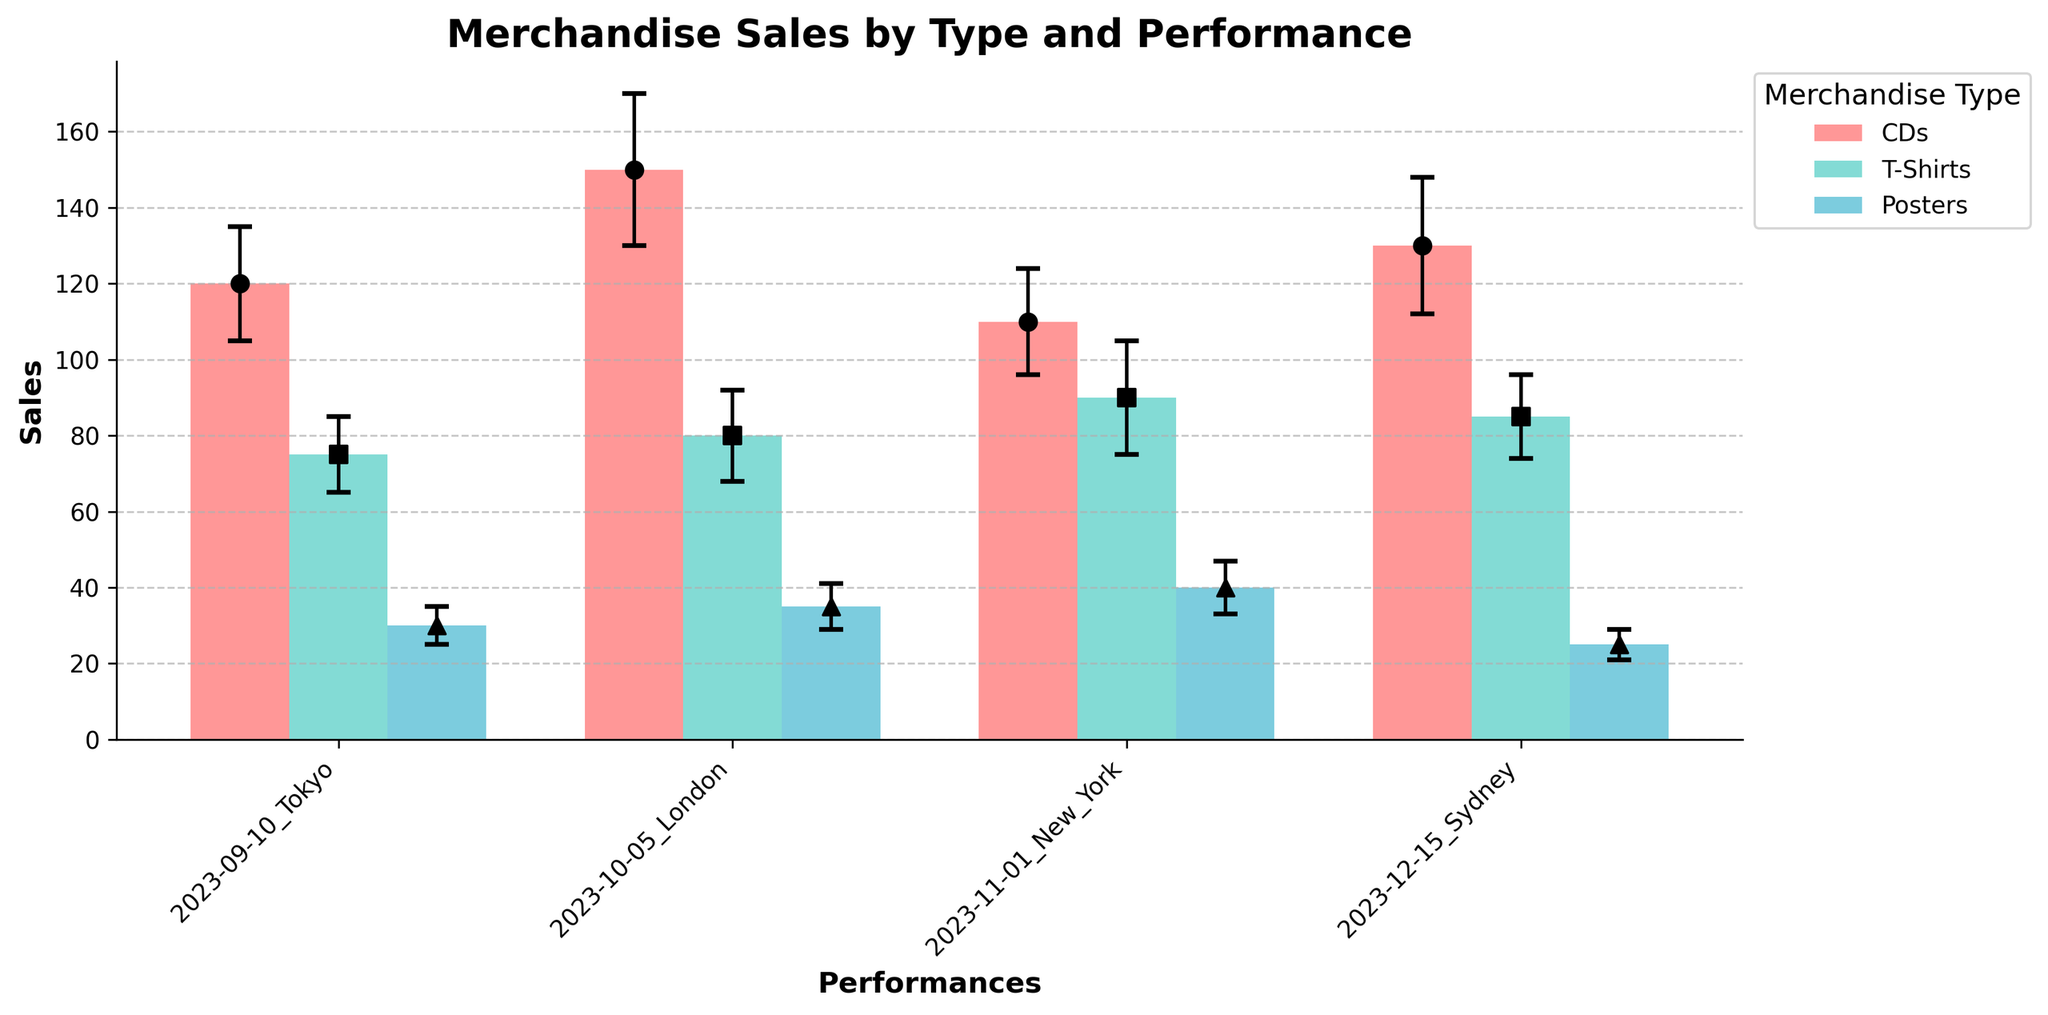What is the title of the plot? The plot title is typically placed at the top of the figure. In this case, the title is "Merchandise Sales by Type and Performance," clearly indicating the content of the plot.
Answer: Merchandise Sales by Type and Performance How many performance locations are shown in the plot? The performance locations can be identified by looking at the x-axis labels of the plot. In this case, the labels are "2023-09-10_Tokyo," "2023-10-05_London," "2023-11-01_New_York," and "2023-12-15_Sydney," which means there are four performance locations.
Answer: 4 Which merchandise type consistently shows the highest mean sales across all performances? By comparing the mean sales bars for each merchandise type across all performances, it is evident that CDs consistently have the highest mean sales compared to T-Shirts and Posters.
Answer: CDs What is the mean sales value of T-Shirts in London? To find this value, look at the bar representing T-Shirt sales for the "2023-10-05_London" performance. The mean sales value for T-Shirts in London is given as 80.
Answer: 80 What is the error margin for Poster sales in New York? Error margins are represented by the error bars extending above and below the mean sales bars. For Posters in New York (2023-11-01), the error margin is given as 7.
Answer: 7 Which performance location has the lowest mean sales for Posters, and what is the value? By comparing the heights of the bars for Poster sales across all locations, the lowest mean sales value for Posters is in Sydney (2023-12-15) with a value of 25.
Answer: Sydney, 25 Which performance has the highest variance in mean sales for T-Shirts? Variance can be estimated by looking at the error bars (standard error) associated with the means. Since New York (2023-11-01) has the largest error bar for T-Shirts (an error of 15), it has the highest variance in mean sales for T-Shirts.
Answer: New York How do CD sales in New York compare to CD sales in Tokyo? To answer this, compare the mean sales bars for CDs in New York (2023-11-01) and Tokyo (2023-09-10). CD sales in New York are 110, while in Tokyo they are 120, indicating Tokyo has higher CD sales.
Answer: Tokyo has higher What is the average mean sales of CDs across all performances? Calculate this by adding the mean sales of CDs for all performances and dividing by the number of performances: (120 + 150 + 110 + 130) / 4 = 127.5.
Answer: 127.5 Which merchandise type has the smallest average error margin across all performances? To find the smallest average error margin, calculate the average error for each merchandise type:
- CDs: (15 + 20 + 14 + 18) / 4 = 16.75
- T-Shirts: (10 + 12 + 15 + 11) / 4 = 12
- Posters: (5 + 6 + 7 + 4) / 4 = 5.5.
Posters have the smallest average error margin.
Answer: Posters 